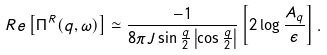<formula> <loc_0><loc_0><loc_500><loc_500>R e \left [ \Pi ^ { R } ( q , \omega ) \right ] \simeq \frac { - 1 } { 8 \pi J \sin \frac { q } { 2 } \left | \cos \frac { q } { 2 } \right | } \left [ 2 \log \frac { A _ { q } } { \epsilon } \right ] .</formula> 